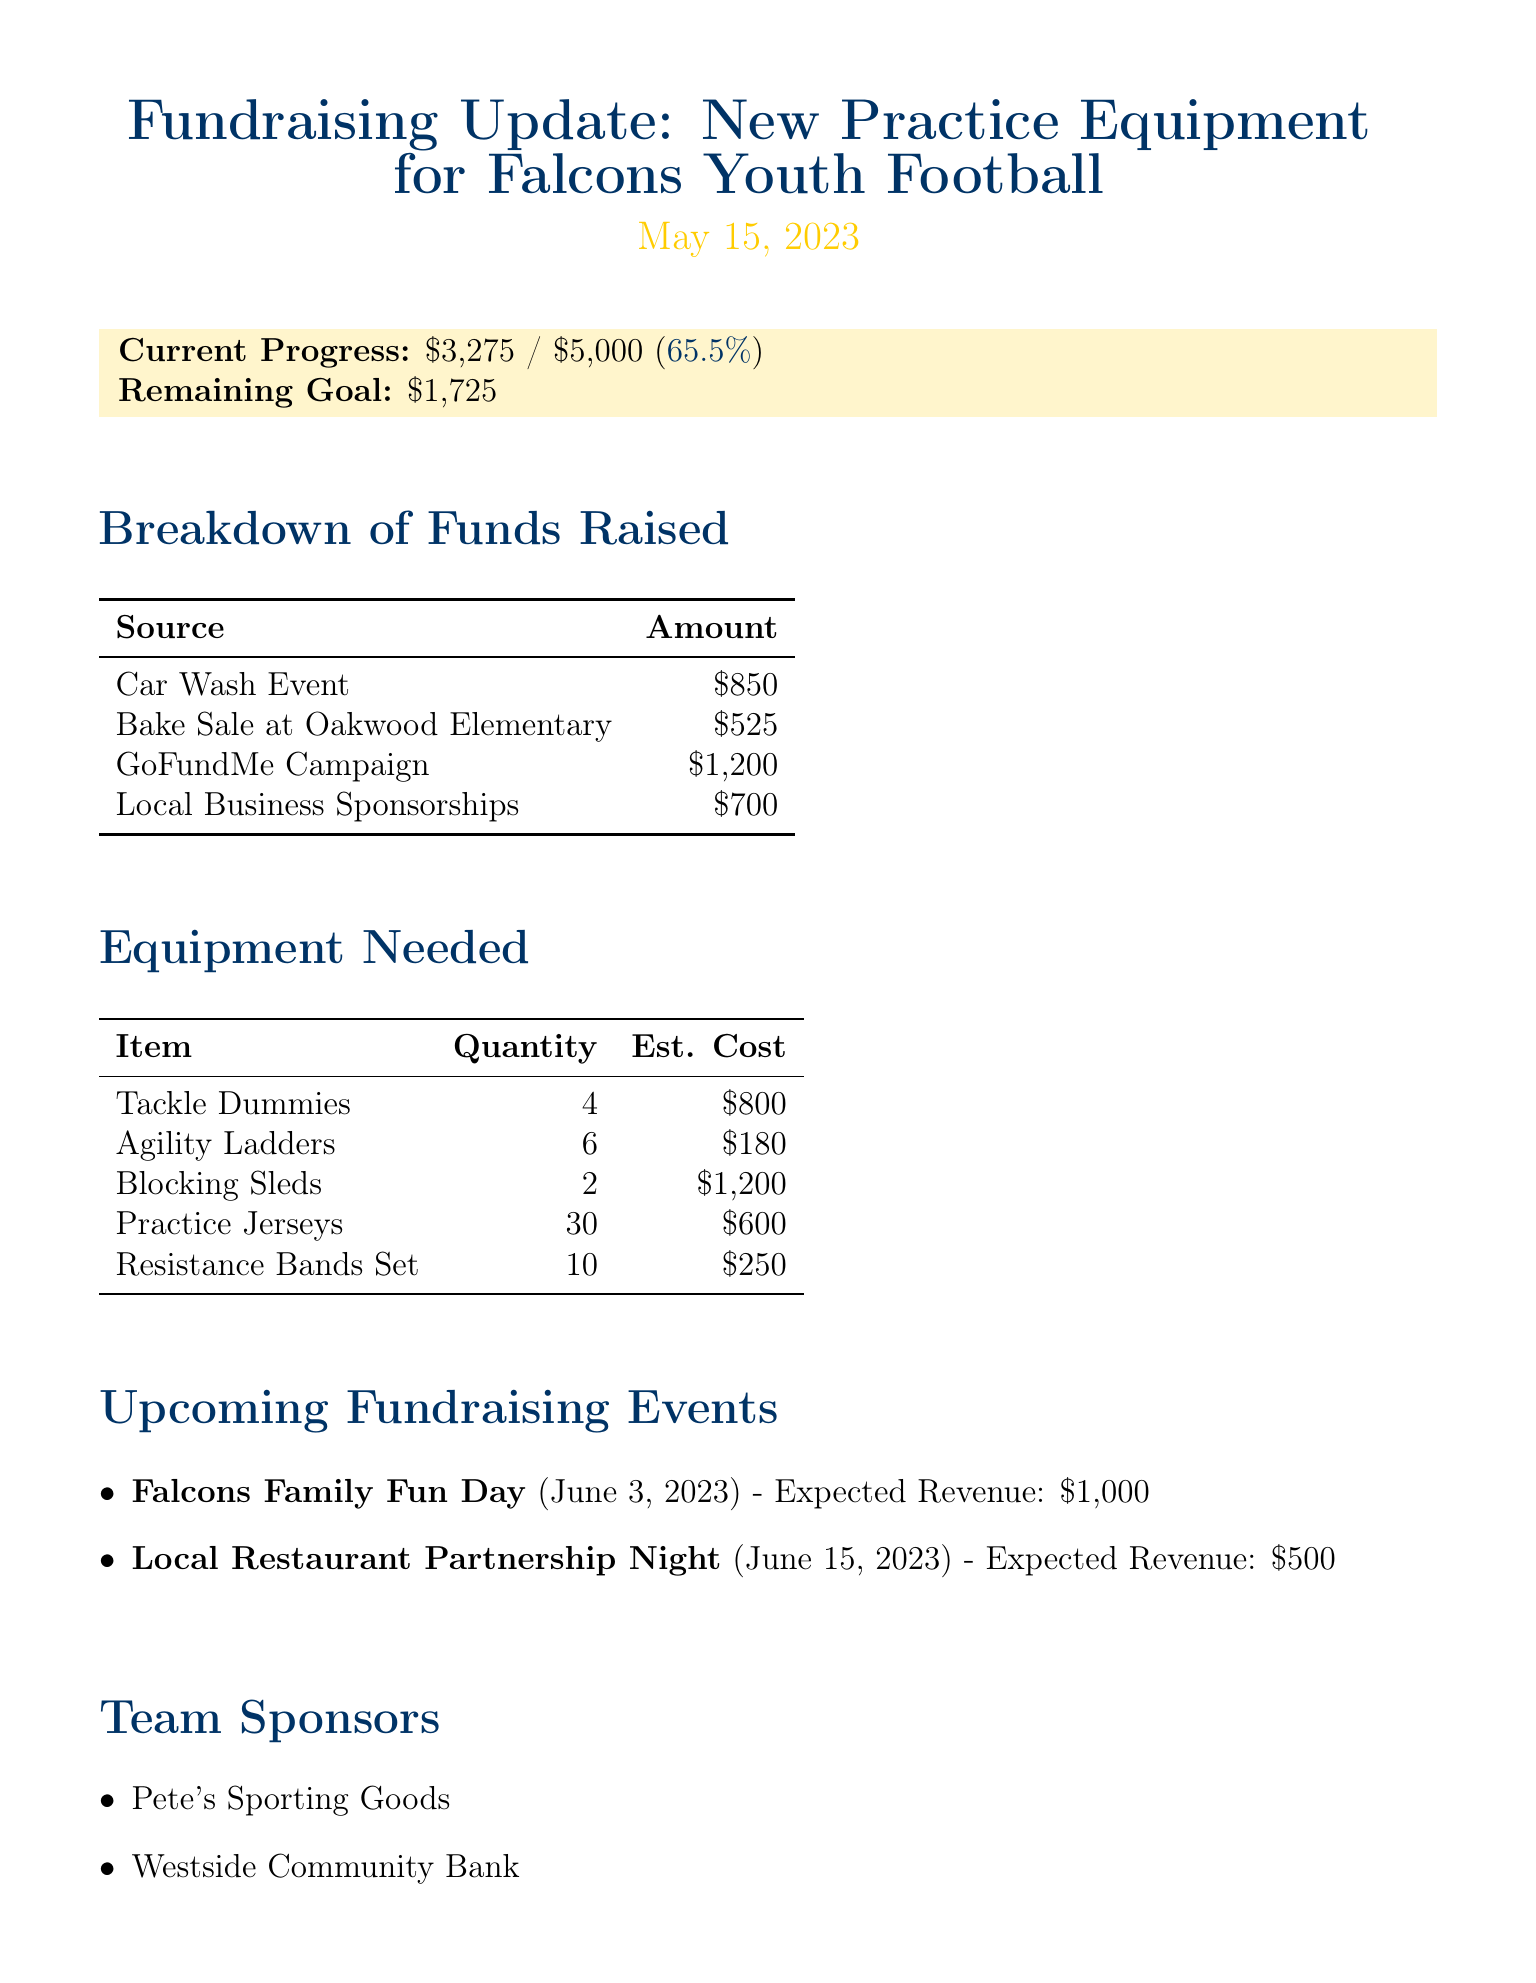What is the total fundraising goal? The total fundraising goal is stated clearly in the memo as $5000.
Answer: $5000 How much has been raised so far? The current progress of funds raised is directly mentioned in the document as $3275.
Answer: $3275 What is the remaining amount needed to reach the goal? The memo specifies that the remaining amount to reach the fundraising goal is $1725.
Answer: $1725 What is the expected revenue from the Falcons Family Fun Day? The expected revenue from the upcoming Falcons Family Fun Day event is given as $1000.
Answer: $1000 Which business is listed as a team sponsor? The memo lists multiple team sponsors, one of which is "Pete's Sporting Goods."
Answer: Pete's Sporting Goods How many Tackle Dummies are needed? The quantity of Tackle Dummies needed is stated in the equipment needed section as 4.
Answer: 4 What is the total estimated cost of Blocking Sleds? The estimated cost of 2 Blocking Sleds is mentioned as $1200.
Answer: $1200 What is one of the next steps mentioned in the memo? One of the next steps is "Reach out to Riverside High School for potential equipment donation," which is noted in the document.
Answer: Reach out to Riverside High School for potential equipment donation What is the date of the Local Restaurant Partnership Night? The date of the Local Restaurant Partnership Night is June 15, 2023, as indicated in the upcoming events section.
Answer: June 15, 2023 